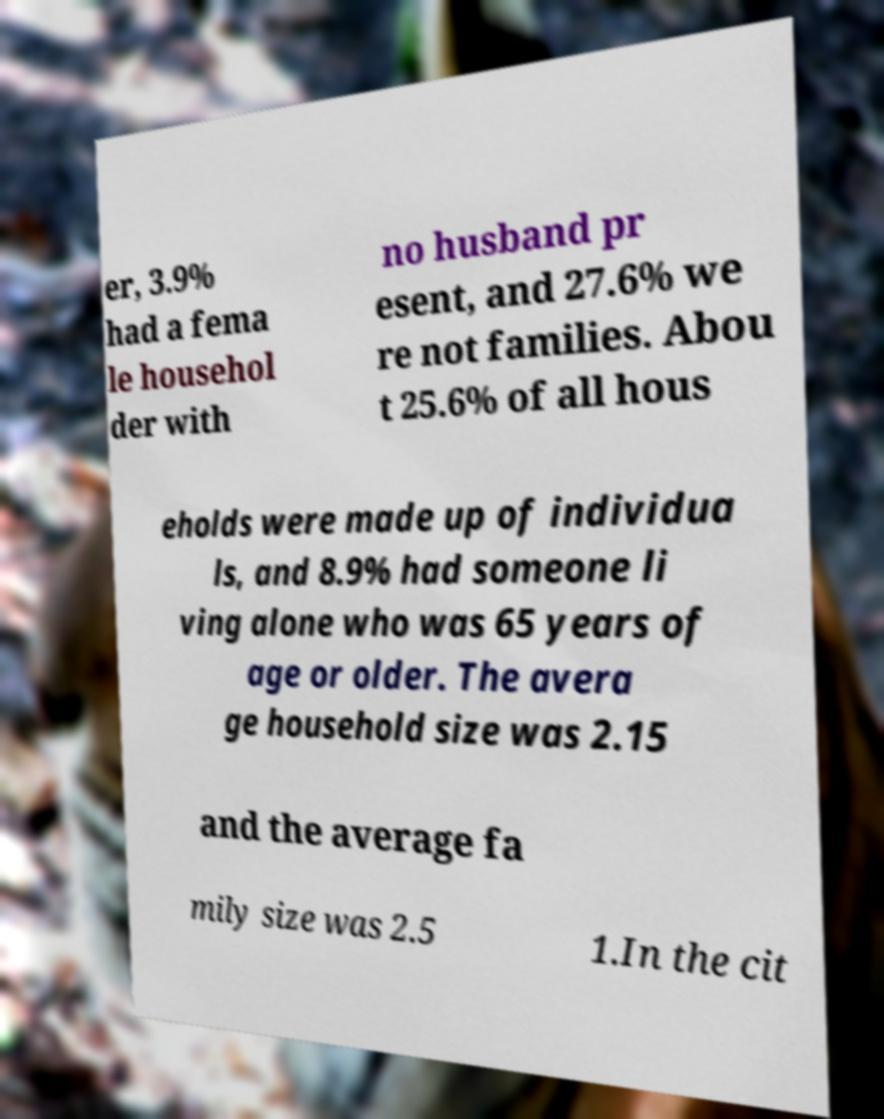There's text embedded in this image that I need extracted. Can you transcribe it verbatim? er, 3.9% had a fema le househol der with no husband pr esent, and 27.6% we re not families. Abou t 25.6% of all hous eholds were made up of individua ls, and 8.9% had someone li ving alone who was 65 years of age or older. The avera ge household size was 2.15 and the average fa mily size was 2.5 1.In the cit 